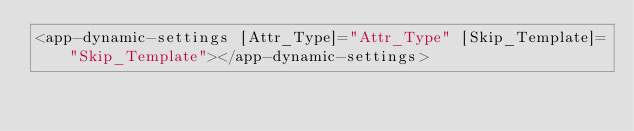<code> <loc_0><loc_0><loc_500><loc_500><_HTML_><app-dynamic-settings [Attr_Type]="Attr_Type" [Skip_Template]="Skip_Template"></app-dynamic-settings></code> 